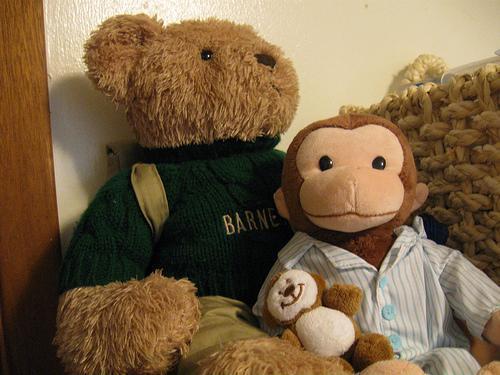How many animals are shown?
Give a very brief answer. 3. How many bears are present?
Give a very brief answer. 2. How many stuffed animals are pictured?
Give a very brief answer. 3. 